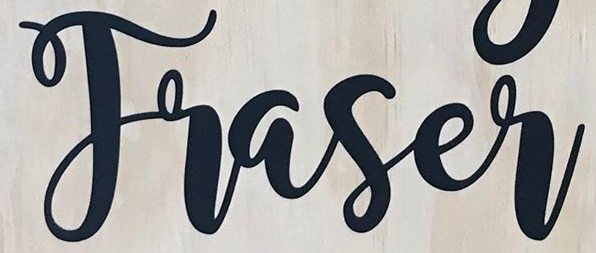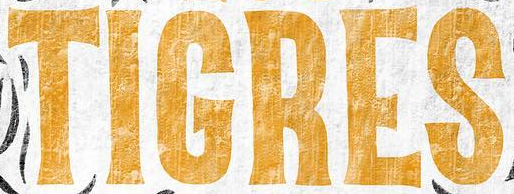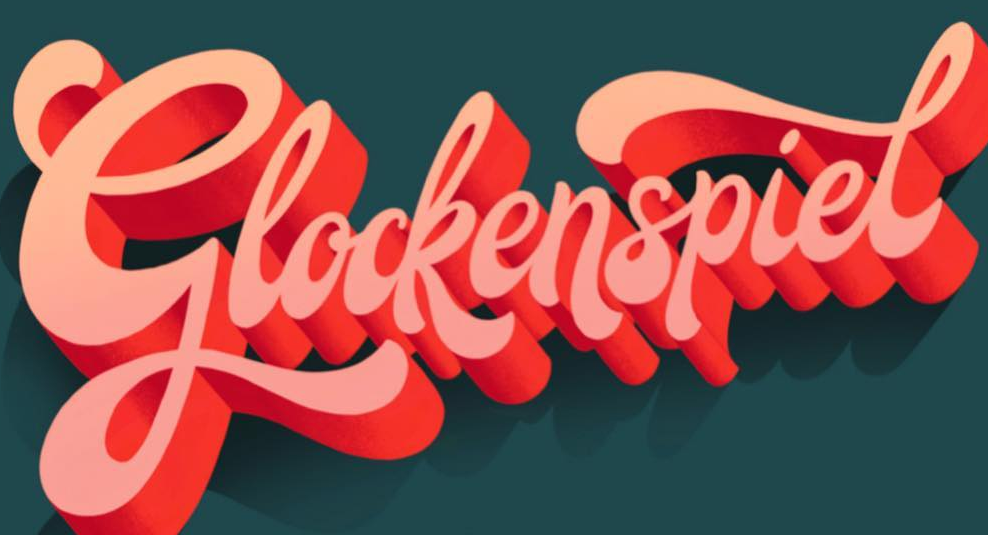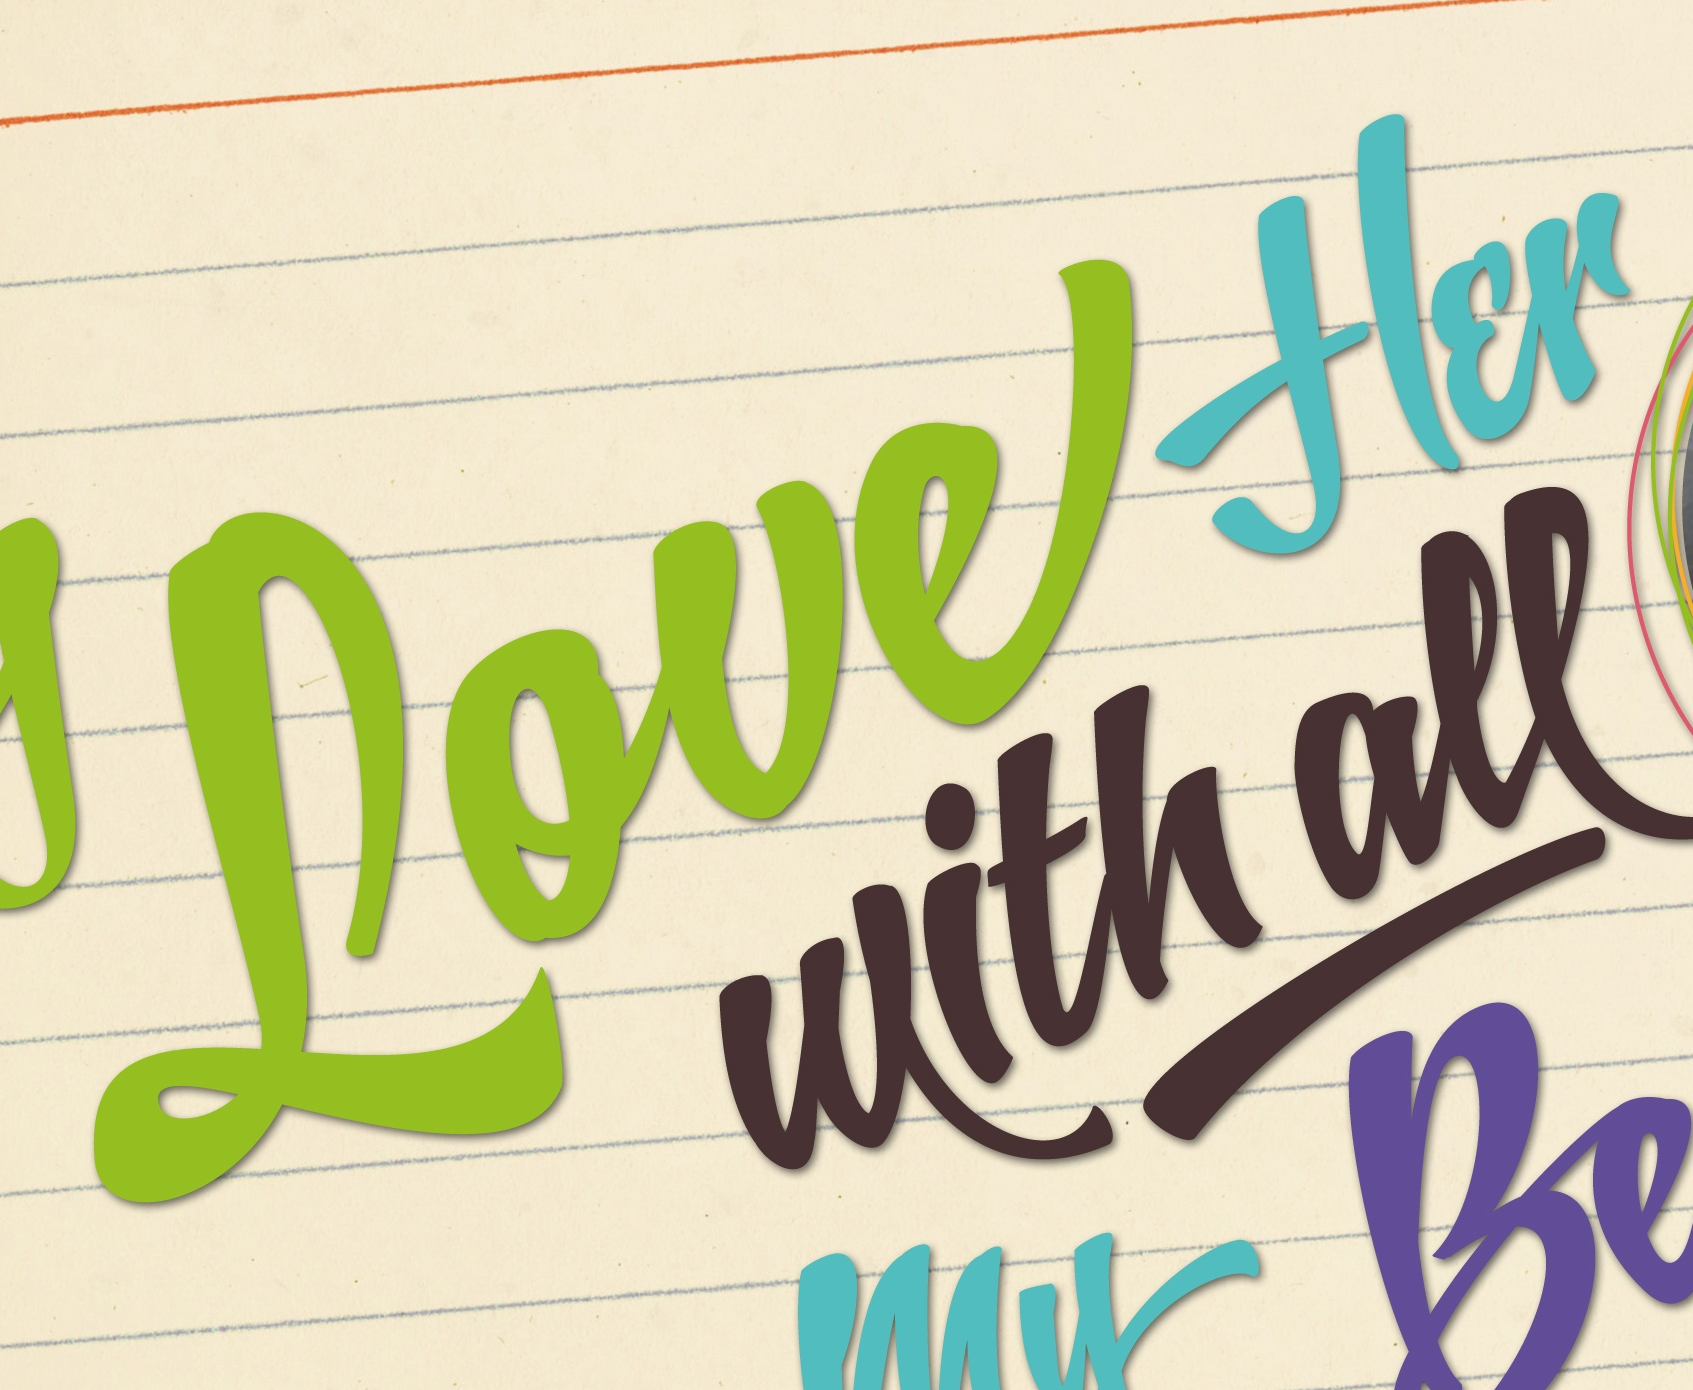Read the text content from these images in order, separated by a semicolon. Traser; TIGRES; Glockenspiel; Loueflɛr 